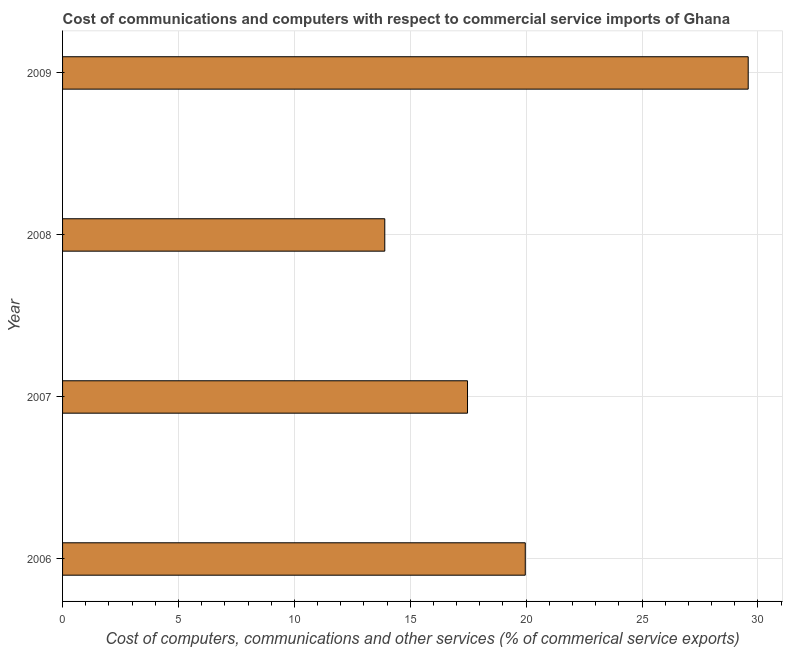What is the title of the graph?
Ensure brevity in your answer.  Cost of communications and computers with respect to commercial service imports of Ghana. What is the label or title of the X-axis?
Give a very brief answer. Cost of computers, communications and other services (% of commerical service exports). What is the label or title of the Y-axis?
Your answer should be compact. Year. What is the  computer and other services in 2006?
Give a very brief answer. 19.96. Across all years, what is the maximum  computer and other services?
Your response must be concise. 29.58. Across all years, what is the minimum cost of communications?
Offer a very short reply. 13.9. In which year was the cost of communications maximum?
Keep it short and to the point. 2009. What is the sum of the cost of communications?
Offer a terse response. 80.91. What is the difference between the  computer and other services in 2006 and 2009?
Keep it short and to the point. -9.62. What is the average  computer and other services per year?
Provide a short and direct response. 20.23. What is the median  computer and other services?
Ensure brevity in your answer.  18.72. In how many years, is the  computer and other services greater than 6 %?
Offer a terse response. 4. What is the ratio of the cost of communications in 2007 to that in 2008?
Offer a terse response. 1.26. Is the  computer and other services in 2006 less than that in 2007?
Your answer should be compact. No. Is the difference between the cost of communications in 2006 and 2007 greater than the difference between any two years?
Provide a succinct answer. No. What is the difference between the highest and the second highest cost of communications?
Offer a terse response. 9.62. What is the difference between the highest and the lowest  computer and other services?
Provide a succinct answer. 15.68. In how many years, is the cost of communications greater than the average cost of communications taken over all years?
Offer a terse response. 1. How many bars are there?
Keep it short and to the point. 4. How many years are there in the graph?
Your response must be concise. 4. What is the difference between two consecutive major ticks on the X-axis?
Offer a very short reply. 5. Are the values on the major ticks of X-axis written in scientific E-notation?
Keep it short and to the point. No. What is the Cost of computers, communications and other services (% of commerical service exports) of 2006?
Offer a terse response. 19.96. What is the Cost of computers, communications and other services (% of commerical service exports) of 2007?
Offer a terse response. 17.47. What is the Cost of computers, communications and other services (% of commerical service exports) in 2008?
Ensure brevity in your answer.  13.9. What is the Cost of computers, communications and other services (% of commerical service exports) in 2009?
Provide a short and direct response. 29.58. What is the difference between the Cost of computers, communications and other services (% of commerical service exports) in 2006 and 2007?
Offer a very short reply. 2.49. What is the difference between the Cost of computers, communications and other services (% of commerical service exports) in 2006 and 2008?
Offer a very short reply. 6.06. What is the difference between the Cost of computers, communications and other services (% of commerical service exports) in 2006 and 2009?
Provide a succinct answer. -9.62. What is the difference between the Cost of computers, communications and other services (% of commerical service exports) in 2007 and 2008?
Ensure brevity in your answer.  3.57. What is the difference between the Cost of computers, communications and other services (% of commerical service exports) in 2007 and 2009?
Keep it short and to the point. -12.11. What is the difference between the Cost of computers, communications and other services (% of commerical service exports) in 2008 and 2009?
Give a very brief answer. -15.68. What is the ratio of the Cost of computers, communications and other services (% of commerical service exports) in 2006 to that in 2007?
Ensure brevity in your answer.  1.14. What is the ratio of the Cost of computers, communications and other services (% of commerical service exports) in 2006 to that in 2008?
Make the answer very short. 1.44. What is the ratio of the Cost of computers, communications and other services (% of commerical service exports) in 2006 to that in 2009?
Provide a short and direct response. 0.68. What is the ratio of the Cost of computers, communications and other services (% of commerical service exports) in 2007 to that in 2008?
Make the answer very short. 1.26. What is the ratio of the Cost of computers, communications and other services (% of commerical service exports) in 2007 to that in 2009?
Ensure brevity in your answer.  0.59. What is the ratio of the Cost of computers, communications and other services (% of commerical service exports) in 2008 to that in 2009?
Give a very brief answer. 0.47. 